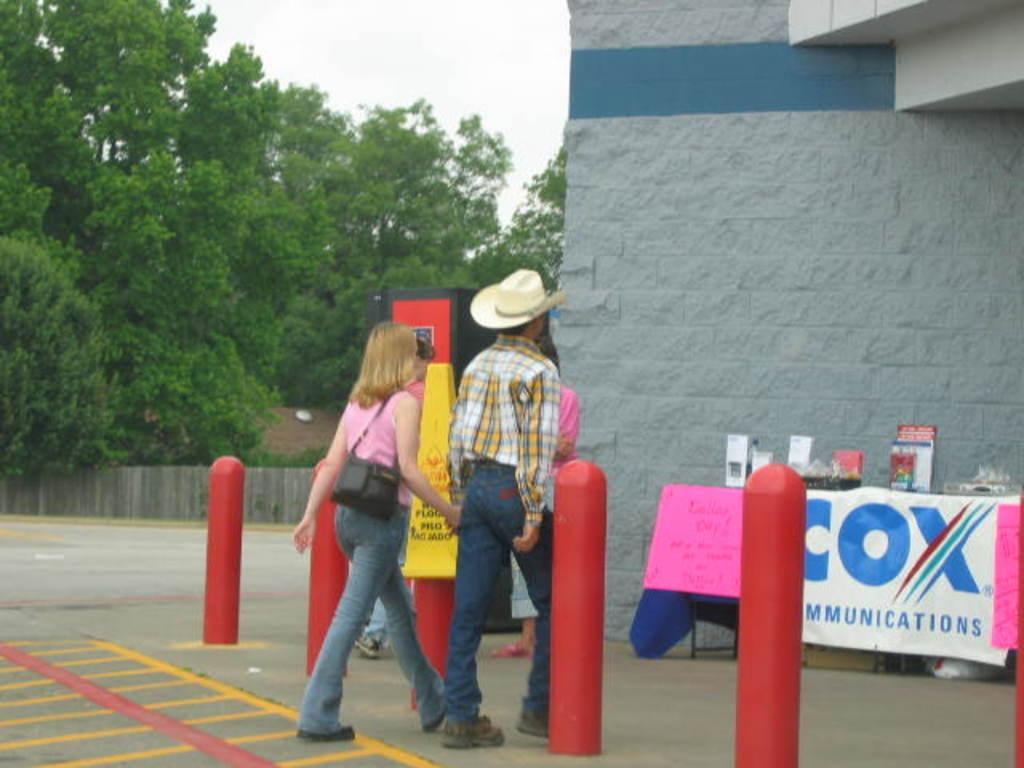Describe this image in one or two sentences. In this image, we can see people wearing clothes. There is a table in the bottom right of the image contains some objects. There is a wall on the right side of the image. There are some trees in the middle of the image. There are poles at the bottom of the image. At the top of the image, we can see the sky. 